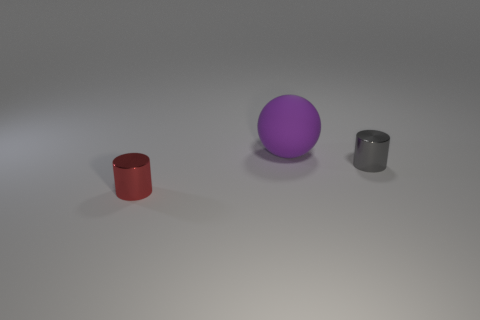How big is the shiny cylinder that is in front of the cylinder to the right of the small cylinder in front of the gray thing?
Keep it short and to the point. Small. What number of other objects are there of the same size as the sphere?
Ensure brevity in your answer.  0. How many tiny red cylinders are made of the same material as the gray thing?
Offer a terse response. 1. There is a gray object in front of the large purple object; what shape is it?
Ensure brevity in your answer.  Cylinder. Do the sphere and the small cylinder right of the big sphere have the same material?
Your answer should be very brief. No. Are there any gray cylinders?
Provide a short and direct response. Yes. Is there a big purple ball to the right of the metallic thing that is left of the metallic cylinder that is to the right of the red object?
Ensure brevity in your answer.  Yes. What number of large objects are either gray metallic cylinders or cyan metallic things?
Provide a succinct answer. 0. What is the color of the cylinder that is the same size as the red object?
Your answer should be very brief. Gray. What number of small gray things are to the left of the red cylinder?
Keep it short and to the point. 0. 